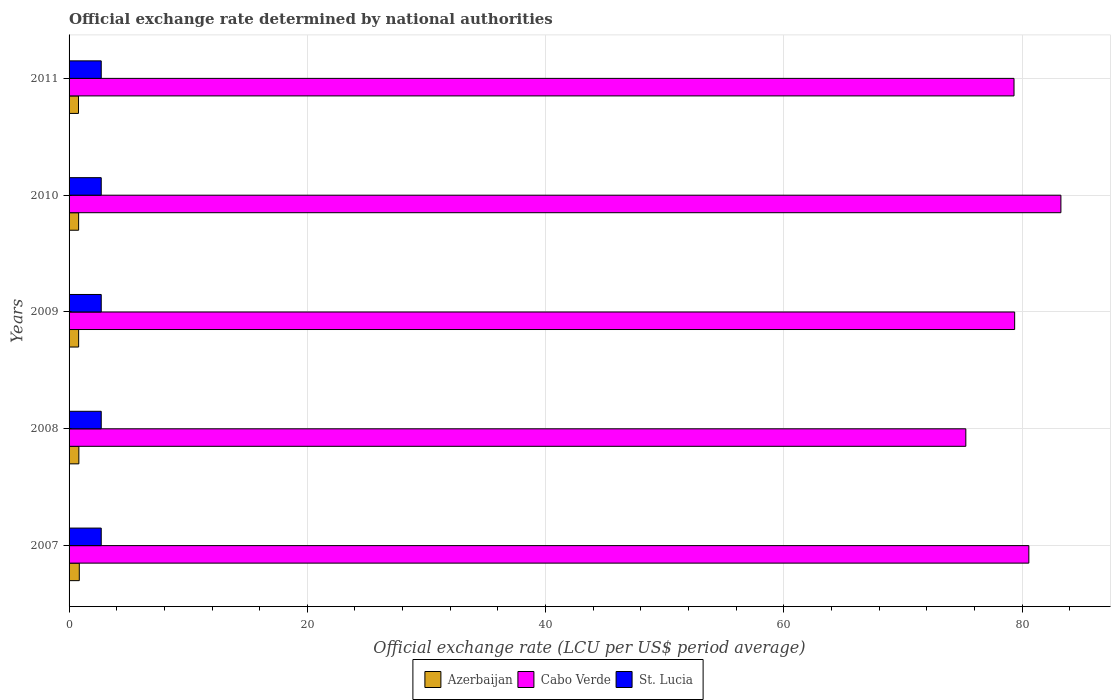How many different coloured bars are there?
Your answer should be compact. 3. Are the number of bars per tick equal to the number of legend labels?
Your answer should be very brief. Yes. What is the label of the 4th group of bars from the top?
Your answer should be compact. 2008. Across all years, what is the maximum official exchange rate in Azerbaijan?
Make the answer very short. 0.86. Across all years, what is the minimum official exchange rate in Cabo Verde?
Ensure brevity in your answer.  75.28. In which year was the official exchange rate in Cabo Verde maximum?
Keep it short and to the point. 2010. In which year was the official exchange rate in Azerbaijan minimum?
Your answer should be compact. 2011. What is the total official exchange rate in Azerbaijan in the graph?
Keep it short and to the point. 4.08. What is the difference between the official exchange rate in Cabo Verde in 2008 and that in 2010?
Provide a short and direct response. -7.98. What is the difference between the official exchange rate in Cabo Verde in 2011 and the official exchange rate in St. Lucia in 2007?
Offer a very short reply. 76.62. What is the average official exchange rate in Cabo Verde per year?
Give a very brief answer. 79.56. In the year 2010, what is the difference between the official exchange rate in St. Lucia and official exchange rate in Cabo Verde?
Make the answer very short. -80.56. In how many years, is the official exchange rate in St. Lucia greater than 72 LCU?
Your answer should be compact. 0. What is the difference between the highest and the second highest official exchange rate in Cabo Verde?
Your response must be concise. 2.69. In how many years, is the official exchange rate in Azerbaijan greater than the average official exchange rate in Azerbaijan taken over all years?
Offer a very short reply. 2. Is the sum of the official exchange rate in St. Lucia in 2008 and 2009 greater than the maximum official exchange rate in Azerbaijan across all years?
Provide a succinct answer. Yes. What does the 1st bar from the top in 2011 represents?
Provide a short and direct response. St. Lucia. What does the 1st bar from the bottom in 2008 represents?
Provide a short and direct response. Azerbaijan. Is it the case that in every year, the sum of the official exchange rate in St. Lucia and official exchange rate in Cabo Verde is greater than the official exchange rate in Azerbaijan?
Give a very brief answer. Yes. Does the graph contain any zero values?
Make the answer very short. No. Does the graph contain grids?
Provide a short and direct response. Yes. Where does the legend appear in the graph?
Make the answer very short. Bottom center. How many legend labels are there?
Offer a very short reply. 3. How are the legend labels stacked?
Make the answer very short. Horizontal. What is the title of the graph?
Provide a short and direct response. Official exchange rate determined by national authorities. Does "India" appear as one of the legend labels in the graph?
Make the answer very short. No. What is the label or title of the X-axis?
Provide a succinct answer. Official exchange rate (LCU per US$ period average). What is the Official exchange rate (LCU per US$ period average) of Azerbaijan in 2007?
Your response must be concise. 0.86. What is the Official exchange rate (LCU per US$ period average) of Cabo Verde in 2007?
Offer a terse response. 80.57. What is the Official exchange rate (LCU per US$ period average) in St. Lucia in 2007?
Give a very brief answer. 2.7. What is the Official exchange rate (LCU per US$ period average) in Azerbaijan in 2008?
Offer a terse response. 0.82. What is the Official exchange rate (LCU per US$ period average) in Cabo Verde in 2008?
Make the answer very short. 75.28. What is the Official exchange rate (LCU per US$ period average) of Azerbaijan in 2009?
Provide a succinct answer. 0.8. What is the Official exchange rate (LCU per US$ period average) in Cabo Verde in 2009?
Give a very brief answer. 79.38. What is the Official exchange rate (LCU per US$ period average) of Azerbaijan in 2010?
Your response must be concise. 0.8. What is the Official exchange rate (LCU per US$ period average) in Cabo Verde in 2010?
Keep it short and to the point. 83.26. What is the Official exchange rate (LCU per US$ period average) in Azerbaijan in 2011?
Keep it short and to the point. 0.79. What is the Official exchange rate (LCU per US$ period average) in Cabo Verde in 2011?
Offer a very short reply. 79.32. Across all years, what is the maximum Official exchange rate (LCU per US$ period average) of Azerbaijan?
Provide a succinct answer. 0.86. Across all years, what is the maximum Official exchange rate (LCU per US$ period average) of Cabo Verde?
Provide a succinct answer. 83.26. Across all years, what is the minimum Official exchange rate (LCU per US$ period average) of Azerbaijan?
Your answer should be very brief. 0.79. Across all years, what is the minimum Official exchange rate (LCU per US$ period average) in Cabo Verde?
Provide a short and direct response. 75.28. Across all years, what is the minimum Official exchange rate (LCU per US$ period average) in St. Lucia?
Make the answer very short. 2.7. What is the total Official exchange rate (LCU per US$ period average) of Azerbaijan in the graph?
Give a very brief answer. 4.08. What is the total Official exchange rate (LCU per US$ period average) of Cabo Verde in the graph?
Ensure brevity in your answer.  397.81. What is the difference between the Official exchange rate (LCU per US$ period average) in Azerbaijan in 2007 and that in 2008?
Give a very brief answer. 0.04. What is the difference between the Official exchange rate (LCU per US$ period average) of Cabo Verde in 2007 and that in 2008?
Keep it short and to the point. 5.29. What is the difference between the Official exchange rate (LCU per US$ period average) of St. Lucia in 2007 and that in 2008?
Ensure brevity in your answer.  0. What is the difference between the Official exchange rate (LCU per US$ period average) in Azerbaijan in 2007 and that in 2009?
Keep it short and to the point. 0.05. What is the difference between the Official exchange rate (LCU per US$ period average) of Cabo Verde in 2007 and that in 2009?
Ensure brevity in your answer.  1.19. What is the difference between the Official exchange rate (LCU per US$ period average) of Azerbaijan in 2007 and that in 2010?
Offer a terse response. 0.06. What is the difference between the Official exchange rate (LCU per US$ period average) in Cabo Verde in 2007 and that in 2010?
Keep it short and to the point. -2.69. What is the difference between the Official exchange rate (LCU per US$ period average) of St. Lucia in 2007 and that in 2010?
Your response must be concise. 0. What is the difference between the Official exchange rate (LCU per US$ period average) of Azerbaijan in 2007 and that in 2011?
Ensure brevity in your answer.  0.07. What is the difference between the Official exchange rate (LCU per US$ period average) in Cabo Verde in 2007 and that in 2011?
Your response must be concise. 1.24. What is the difference between the Official exchange rate (LCU per US$ period average) in St. Lucia in 2007 and that in 2011?
Your answer should be compact. 0. What is the difference between the Official exchange rate (LCU per US$ period average) in Azerbaijan in 2008 and that in 2009?
Your answer should be compact. 0.02. What is the difference between the Official exchange rate (LCU per US$ period average) of Cabo Verde in 2008 and that in 2009?
Make the answer very short. -4.1. What is the difference between the Official exchange rate (LCU per US$ period average) in Azerbaijan in 2008 and that in 2010?
Give a very brief answer. 0.02. What is the difference between the Official exchange rate (LCU per US$ period average) in Cabo Verde in 2008 and that in 2010?
Make the answer very short. -7.98. What is the difference between the Official exchange rate (LCU per US$ period average) of Azerbaijan in 2008 and that in 2011?
Keep it short and to the point. 0.03. What is the difference between the Official exchange rate (LCU per US$ period average) in Cabo Verde in 2008 and that in 2011?
Offer a very short reply. -4.04. What is the difference between the Official exchange rate (LCU per US$ period average) in St. Lucia in 2008 and that in 2011?
Provide a short and direct response. 0. What is the difference between the Official exchange rate (LCU per US$ period average) in Azerbaijan in 2009 and that in 2010?
Offer a very short reply. 0. What is the difference between the Official exchange rate (LCU per US$ period average) of Cabo Verde in 2009 and that in 2010?
Offer a terse response. -3.88. What is the difference between the Official exchange rate (LCU per US$ period average) in St. Lucia in 2009 and that in 2010?
Provide a succinct answer. 0. What is the difference between the Official exchange rate (LCU per US$ period average) of Azerbaijan in 2009 and that in 2011?
Offer a very short reply. 0.01. What is the difference between the Official exchange rate (LCU per US$ period average) of Cabo Verde in 2009 and that in 2011?
Your response must be concise. 0.05. What is the difference between the Official exchange rate (LCU per US$ period average) in St. Lucia in 2009 and that in 2011?
Make the answer very short. 0. What is the difference between the Official exchange rate (LCU per US$ period average) in Azerbaijan in 2010 and that in 2011?
Provide a short and direct response. 0.01. What is the difference between the Official exchange rate (LCU per US$ period average) of Cabo Verde in 2010 and that in 2011?
Your response must be concise. 3.94. What is the difference between the Official exchange rate (LCU per US$ period average) of St. Lucia in 2010 and that in 2011?
Your answer should be compact. 0. What is the difference between the Official exchange rate (LCU per US$ period average) in Azerbaijan in 2007 and the Official exchange rate (LCU per US$ period average) in Cabo Verde in 2008?
Give a very brief answer. -74.42. What is the difference between the Official exchange rate (LCU per US$ period average) in Azerbaijan in 2007 and the Official exchange rate (LCU per US$ period average) in St. Lucia in 2008?
Offer a very short reply. -1.84. What is the difference between the Official exchange rate (LCU per US$ period average) in Cabo Verde in 2007 and the Official exchange rate (LCU per US$ period average) in St. Lucia in 2008?
Your answer should be compact. 77.87. What is the difference between the Official exchange rate (LCU per US$ period average) of Azerbaijan in 2007 and the Official exchange rate (LCU per US$ period average) of Cabo Verde in 2009?
Your answer should be very brief. -78.52. What is the difference between the Official exchange rate (LCU per US$ period average) in Azerbaijan in 2007 and the Official exchange rate (LCU per US$ period average) in St. Lucia in 2009?
Your response must be concise. -1.84. What is the difference between the Official exchange rate (LCU per US$ period average) of Cabo Verde in 2007 and the Official exchange rate (LCU per US$ period average) of St. Lucia in 2009?
Provide a short and direct response. 77.87. What is the difference between the Official exchange rate (LCU per US$ period average) of Azerbaijan in 2007 and the Official exchange rate (LCU per US$ period average) of Cabo Verde in 2010?
Your answer should be compact. -82.4. What is the difference between the Official exchange rate (LCU per US$ period average) of Azerbaijan in 2007 and the Official exchange rate (LCU per US$ period average) of St. Lucia in 2010?
Your answer should be very brief. -1.84. What is the difference between the Official exchange rate (LCU per US$ period average) in Cabo Verde in 2007 and the Official exchange rate (LCU per US$ period average) in St. Lucia in 2010?
Your answer should be compact. 77.87. What is the difference between the Official exchange rate (LCU per US$ period average) in Azerbaijan in 2007 and the Official exchange rate (LCU per US$ period average) in Cabo Verde in 2011?
Offer a very short reply. -78.47. What is the difference between the Official exchange rate (LCU per US$ period average) in Azerbaijan in 2007 and the Official exchange rate (LCU per US$ period average) in St. Lucia in 2011?
Offer a terse response. -1.84. What is the difference between the Official exchange rate (LCU per US$ period average) of Cabo Verde in 2007 and the Official exchange rate (LCU per US$ period average) of St. Lucia in 2011?
Give a very brief answer. 77.87. What is the difference between the Official exchange rate (LCU per US$ period average) of Azerbaijan in 2008 and the Official exchange rate (LCU per US$ period average) of Cabo Verde in 2009?
Your answer should be compact. -78.56. What is the difference between the Official exchange rate (LCU per US$ period average) in Azerbaijan in 2008 and the Official exchange rate (LCU per US$ period average) in St. Lucia in 2009?
Make the answer very short. -1.88. What is the difference between the Official exchange rate (LCU per US$ period average) of Cabo Verde in 2008 and the Official exchange rate (LCU per US$ period average) of St. Lucia in 2009?
Provide a succinct answer. 72.58. What is the difference between the Official exchange rate (LCU per US$ period average) in Azerbaijan in 2008 and the Official exchange rate (LCU per US$ period average) in Cabo Verde in 2010?
Keep it short and to the point. -82.44. What is the difference between the Official exchange rate (LCU per US$ period average) in Azerbaijan in 2008 and the Official exchange rate (LCU per US$ period average) in St. Lucia in 2010?
Offer a terse response. -1.88. What is the difference between the Official exchange rate (LCU per US$ period average) in Cabo Verde in 2008 and the Official exchange rate (LCU per US$ period average) in St. Lucia in 2010?
Your response must be concise. 72.58. What is the difference between the Official exchange rate (LCU per US$ period average) of Azerbaijan in 2008 and the Official exchange rate (LCU per US$ period average) of Cabo Verde in 2011?
Keep it short and to the point. -78.5. What is the difference between the Official exchange rate (LCU per US$ period average) in Azerbaijan in 2008 and the Official exchange rate (LCU per US$ period average) in St. Lucia in 2011?
Make the answer very short. -1.88. What is the difference between the Official exchange rate (LCU per US$ period average) of Cabo Verde in 2008 and the Official exchange rate (LCU per US$ period average) of St. Lucia in 2011?
Keep it short and to the point. 72.58. What is the difference between the Official exchange rate (LCU per US$ period average) in Azerbaijan in 2009 and the Official exchange rate (LCU per US$ period average) in Cabo Verde in 2010?
Your answer should be very brief. -82.45. What is the difference between the Official exchange rate (LCU per US$ period average) in Azerbaijan in 2009 and the Official exchange rate (LCU per US$ period average) in St. Lucia in 2010?
Offer a terse response. -1.9. What is the difference between the Official exchange rate (LCU per US$ period average) of Cabo Verde in 2009 and the Official exchange rate (LCU per US$ period average) of St. Lucia in 2010?
Provide a short and direct response. 76.68. What is the difference between the Official exchange rate (LCU per US$ period average) in Azerbaijan in 2009 and the Official exchange rate (LCU per US$ period average) in Cabo Verde in 2011?
Offer a very short reply. -78.52. What is the difference between the Official exchange rate (LCU per US$ period average) of Azerbaijan in 2009 and the Official exchange rate (LCU per US$ period average) of St. Lucia in 2011?
Your answer should be compact. -1.9. What is the difference between the Official exchange rate (LCU per US$ period average) of Cabo Verde in 2009 and the Official exchange rate (LCU per US$ period average) of St. Lucia in 2011?
Offer a terse response. 76.68. What is the difference between the Official exchange rate (LCU per US$ period average) in Azerbaijan in 2010 and the Official exchange rate (LCU per US$ period average) in Cabo Verde in 2011?
Give a very brief answer. -78.52. What is the difference between the Official exchange rate (LCU per US$ period average) in Azerbaijan in 2010 and the Official exchange rate (LCU per US$ period average) in St. Lucia in 2011?
Make the answer very short. -1.9. What is the difference between the Official exchange rate (LCU per US$ period average) in Cabo Verde in 2010 and the Official exchange rate (LCU per US$ period average) in St. Lucia in 2011?
Your answer should be very brief. 80.56. What is the average Official exchange rate (LCU per US$ period average) of Azerbaijan per year?
Your answer should be very brief. 0.82. What is the average Official exchange rate (LCU per US$ period average) in Cabo Verde per year?
Provide a short and direct response. 79.56. In the year 2007, what is the difference between the Official exchange rate (LCU per US$ period average) of Azerbaijan and Official exchange rate (LCU per US$ period average) of Cabo Verde?
Make the answer very short. -79.71. In the year 2007, what is the difference between the Official exchange rate (LCU per US$ period average) of Azerbaijan and Official exchange rate (LCU per US$ period average) of St. Lucia?
Your answer should be very brief. -1.84. In the year 2007, what is the difference between the Official exchange rate (LCU per US$ period average) in Cabo Verde and Official exchange rate (LCU per US$ period average) in St. Lucia?
Offer a terse response. 77.87. In the year 2008, what is the difference between the Official exchange rate (LCU per US$ period average) of Azerbaijan and Official exchange rate (LCU per US$ period average) of Cabo Verde?
Provide a short and direct response. -74.46. In the year 2008, what is the difference between the Official exchange rate (LCU per US$ period average) of Azerbaijan and Official exchange rate (LCU per US$ period average) of St. Lucia?
Ensure brevity in your answer.  -1.88. In the year 2008, what is the difference between the Official exchange rate (LCU per US$ period average) in Cabo Verde and Official exchange rate (LCU per US$ period average) in St. Lucia?
Ensure brevity in your answer.  72.58. In the year 2009, what is the difference between the Official exchange rate (LCU per US$ period average) in Azerbaijan and Official exchange rate (LCU per US$ period average) in Cabo Verde?
Provide a succinct answer. -78.57. In the year 2009, what is the difference between the Official exchange rate (LCU per US$ period average) of Azerbaijan and Official exchange rate (LCU per US$ period average) of St. Lucia?
Your response must be concise. -1.9. In the year 2009, what is the difference between the Official exchange rate (LCU per US$ period average) in Cabo Verde and Official exchange rate (LCU per US$ period average) in St. Lucia?
Your answer should be compact. 76.68. In the year 2010, what is the difference between the Official exchange rate (LCU per US$ period average) of Azerbaijan and Official exchange rate (LCU per US$ period average) of Cabo Verde?
Provide a short and direct response. -82.46. In the year 2010, what is the difference between the Official exchange rate (LCU per US$ period average) in Azerbaijan and Official exchange rate (LCU per US$ period average) in St. Lucia?
Your answer should be compact. -1.9. In the year 2010, what is the difference between the Official exchange rate (LCU per US$ period average) of Cabo Verde and Official exchange rate (LCU per US$ period average) of St. Lucia?
Keep it short and to the point. 80.56. In the year 2011, what is the difference between the Official exchange rate (LCU per US$ period average) of Azerbaijan and Official exchange rate (LCU per US$ period average) of Cabo Verde?
Keep it short and to the point. -78.53. In the year 2011, what is the difference between the Official exchange rate (LCU per US$ period average) of Azerbaijan and Official exchange rate (LCU per US$ period average) of St. Lucia?
Keep it short and to the point. -1.91. In the year 2011, what is the difference between the Official exchange rate (LCU per US$ period average) in Cabo Verde and Official exchange rate (LCU per US$ period average) in St. Lucia?
Offer a very short reply. 76.62. What is the ratio of the Official exchange rate (LCU per US$ period average) in Azerbaijan in 2007 to that in 2008?
Offer a terse response. 1.04. What is the ratio of the Official exchange rate (LCU per US$ period average) in Cabo Verde in 2007 to that in 2008?
Your response must be concise. 1.07. What is the ratio of the Official exchange rate (LCU per US$ period average) in Azerbaijan in 2007 to that in 2009?
Your answer should be compact. 1.07. What is the ratio of the Official exchange rate (LCU per US$ period average) in Cabo Verde in 2007 to that in 2009?
Ensure brevity in your answer.  1.01. What is the ratio of the Official exchange rate (LCU per US$ period average) of St. Lucia in 2007 to that in 2009?
Make the answer very short. 1. What is the ratio of the Official exchange rate (LCU per US$ period average) of Azerbaijan in 2007 to that in 2010?
Offer a very short reply. 1.07. What is the ratio of the Official exchange rate (LCU per US$ period average) in Cabo Verde in 2007 to that in 2010?
Give a very brief answer. 0.97. What is the ratio of the Official exchange rate (LCU per US$ period average) of Azerbaijan in 2007 to that in 2011?
Offer a very short reply. 1.09. What is the ratio of the Official exchange rate (LCU per US$ period average) in Cabo Verde in 2007 to that in 2011?
Your response must be concise. 1.02. What is the ratio of the Official exchange rate (LCU per US$ period average) of Azerbaijan in 2008 to that in 2009?
Make the answer very short. 1.02. What is the ratio of the Official exchange rate (LCU per US$ period average) in Cabo Verde in 2008 to that in 2009?
Offer a very short reply. 0.95. What is the ratio of the Official exchange rate (LCU per US$ period average) in Azerbaijan in 2008 to that in 2010?
Offer a very short reply. 1.02. What is the ratio of the Official exchange rate (LCU per US$ period average) in Cabo Verde in 2008 to that in 2010?
Provide a short and direct response. 0.9. What is the ratio of the Official exchange rate (LCU per US$ period average) in Azerbaijan in 2008 to that in 2011?
Your response must be concise. 1.04. What is the ratio of the Official exchange rate (LCU per US$ period average) of Cabo Verde in 2008 to that in 2011?
Your answer should be compact. 0.95. What is the ratio of the Official exchange rate (LCU per US$ period average) in St. Lucia in 2008 to that in 2011?
Offer a terse response. 1. What is the ratio of the Official exchange rate (LCU per US$ period average) in Azerbaijan in 2009 to that in 2010?
Offer a very short reply. 1. What is the ratio of the Official exchange rate (LCU per US$ period average) of Cabo Verde in 2009 to that in 2010?
Ensure brevity in your answer.  0.95. What is the ratio of the Official exchange rate (LCU per US$ period average) of Azerbaijan in 2009 to that in 2011?
Provide a short and direct response. 1.02. What is the ratio of the Official exchange rate (LCU per US$ period average) in St. Lucia in 2009 to that in 2011?
Give a very brief answer. 1. What is the ratio of the Official exchange rate (LCU per US$ period average) of Azerbaijan in 2010 to that in 2011?
Offer a very short reply. 1.02. What is the ratio of the Official exchange rate (LCU per US$ period average) in Cabo Verde in 2010 to that in 2011?
Provide a succinct answer. 1.05. What is the ratio of the Official exchange rate (LCU per US$ period average) of St. Lucia in 2010 to that in 2011?
Your response must be concise. 1. What is the difference between the highest and the second highest Official exchange rate (LCU per US$ period average) of Azerbaijan?
Give a very brief answer. 0.04. What is the difference between the highest and the second highest Official exchange rate (LCU per US$ period average) in Cabo Verde?
Your answer should be compact. 2.69. What is the difference between the highest and the second highest Official exchange rate (LCU per US$ period average) in St. Lucia?
Offer a terse response. 0. What is the difference between the highest and the lowest Official exchange rate (LCU per US$ period average) in Azerbaijan?
Offer a terse response. 0.07. What is the difference between the highest and the lowest Official exchange rate (LCU per US$ period average) of Cabo Verde?
Provide a succinct answer. 7.98. 